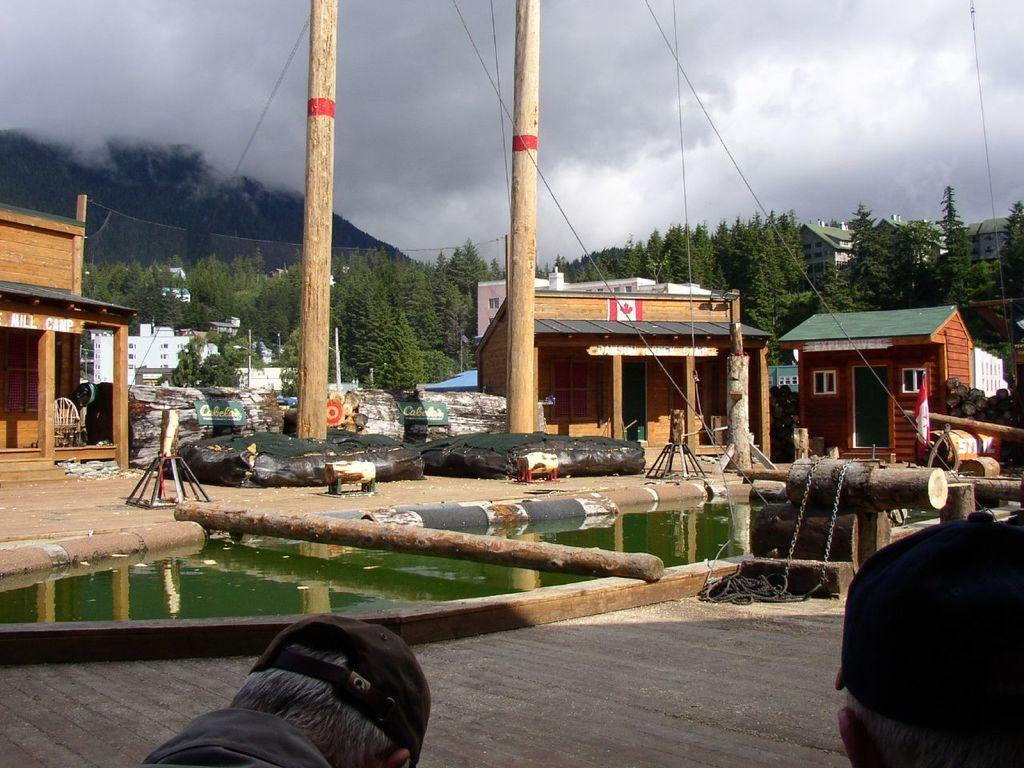What is located in the foreground of the picture? In the foreground of the picture, there are heads of a person, water, a trunk, two poles, and houses. Can you describe the elements in the foreground of the picture? The foreground of the picture includes water, a trunk, two poles, and houses. Additionally, there are heads of a person visible. What can be seen in the background of the picture? In the background of the picture, there is a mountain, trees, and a cloud. How many poles are present in the foreground of the picture? There are two poles in the foreground of the picture. How many boats are visible in the picture? There are no boats present in the picture. What type of horn is being played by the person in the foreground of the picture? There is no horn being played in the picture; only the heads of a person are visible. 